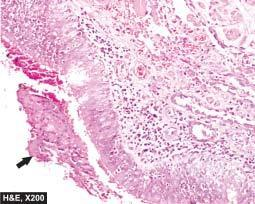what is the bronchial wall thickened by?
Answer the question using a single word or phrase. Acute and chronic inflammatory cells 